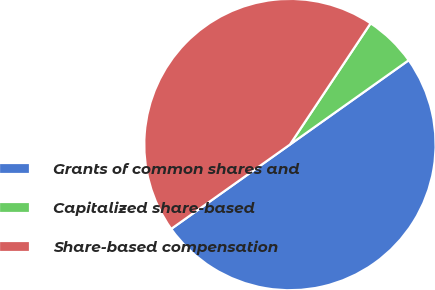Convert chart to OTSL. <chart><loc_0><loc_0><loc_500><loc_500><pie_chart><fcel>Grants of common shares and<fcel>Capitalized share-based<fcel>Share-based compensation<nl><fcel>50.0%<fcel>5.83%<fcel>44.17%<nl></chart> 